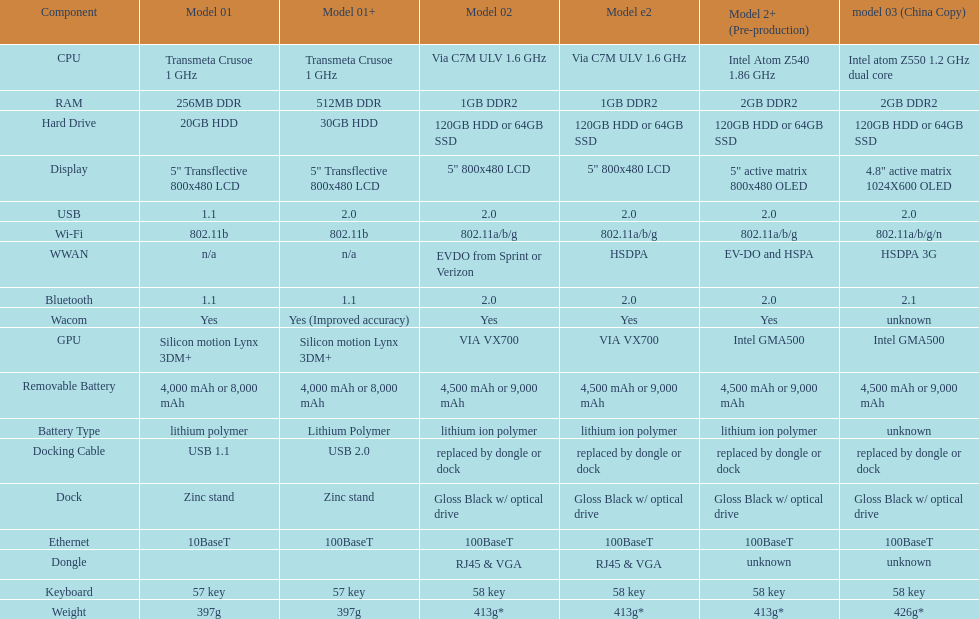0 compatibility? 5. 